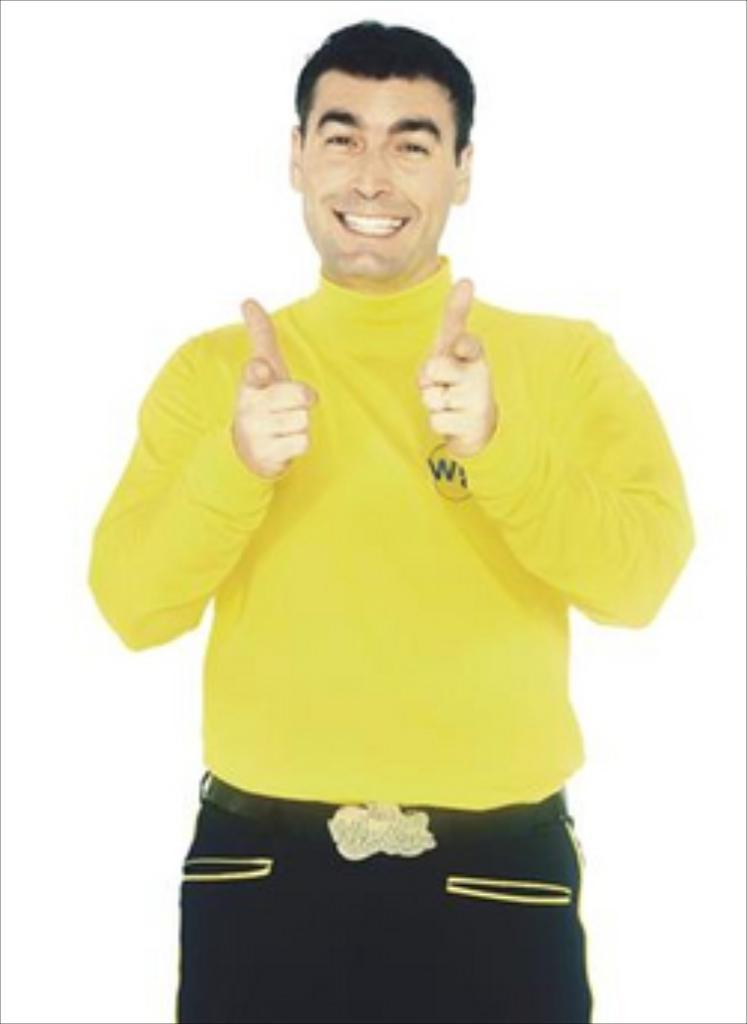What is the main subject of the image? There is a person in the image. What color is the background of the image? The background of the image is white in color. How many tails can be seen on the person in the image? There are no tails visible on the person in the image. What type of dogs are present in the image? There are no dogs present in the image. 